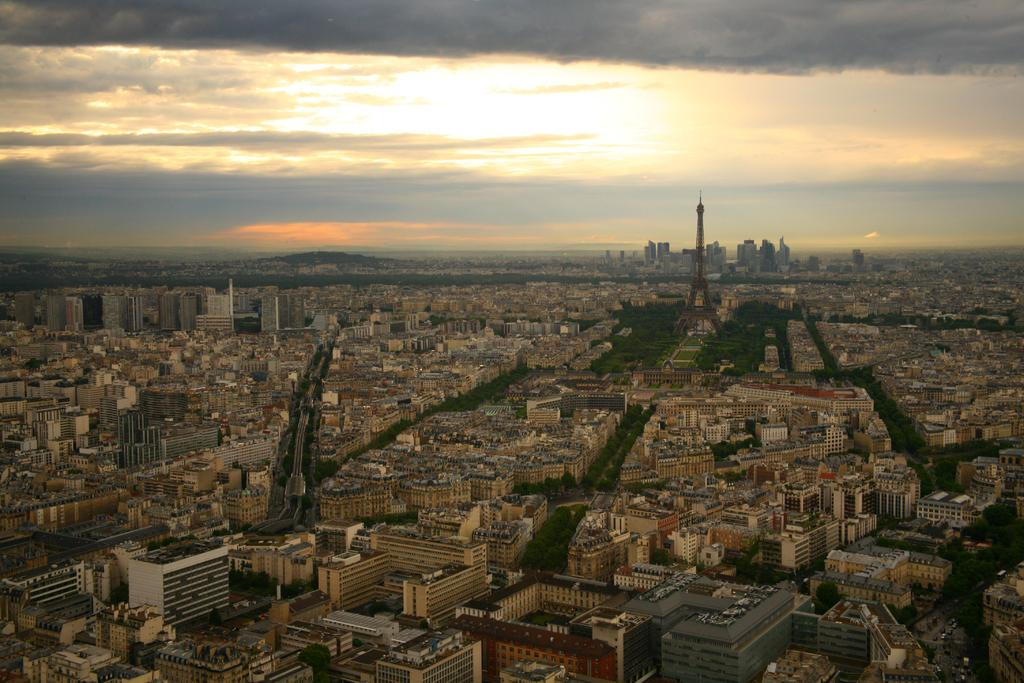What type of structures are present in the image? There is a group of buildings in the image. What other natural elements can be seen in the image? There are trees in the image. What is visible in the background of the image? The sky is visible in the background of the image. What type of cord or wire is hanging from the trees in the image? There is no cord or wire hanging from the trees in the image; only buildings, trees, and the sky are present. 